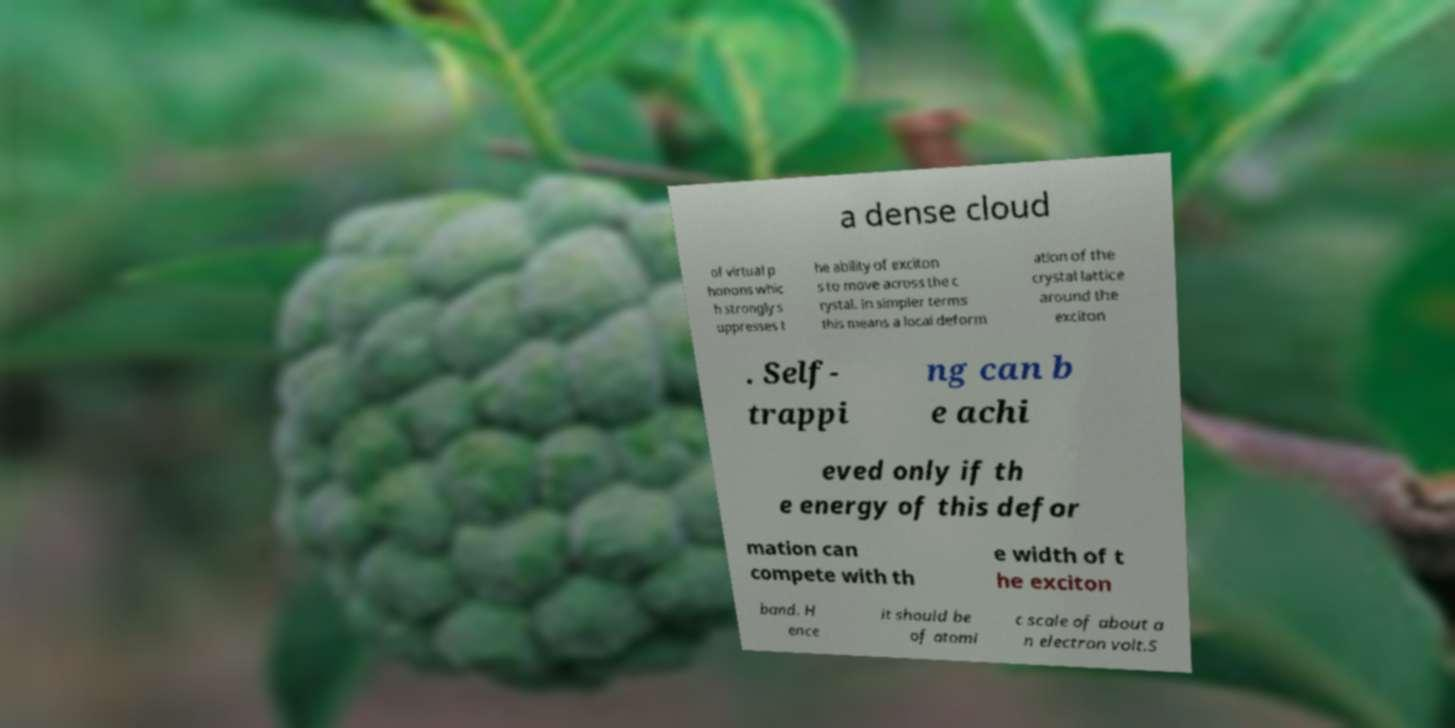Can you read and provide the text displayed in the image?This photo seems to have some interesting text. Can you extract and type it out for me? a dense cloud of virtual p honons whic h strongly s uppresses t he ability of exciton s to move across the c rystal. In simpler terms this means a local deform ation of the crystal lattice around the exciton . Self- trappi ng can b e achi eved only if th e energy of this defor mation can compete with th e width of t he exciton band. H ence it should be of atomi c scale of about a n electron volt.S 